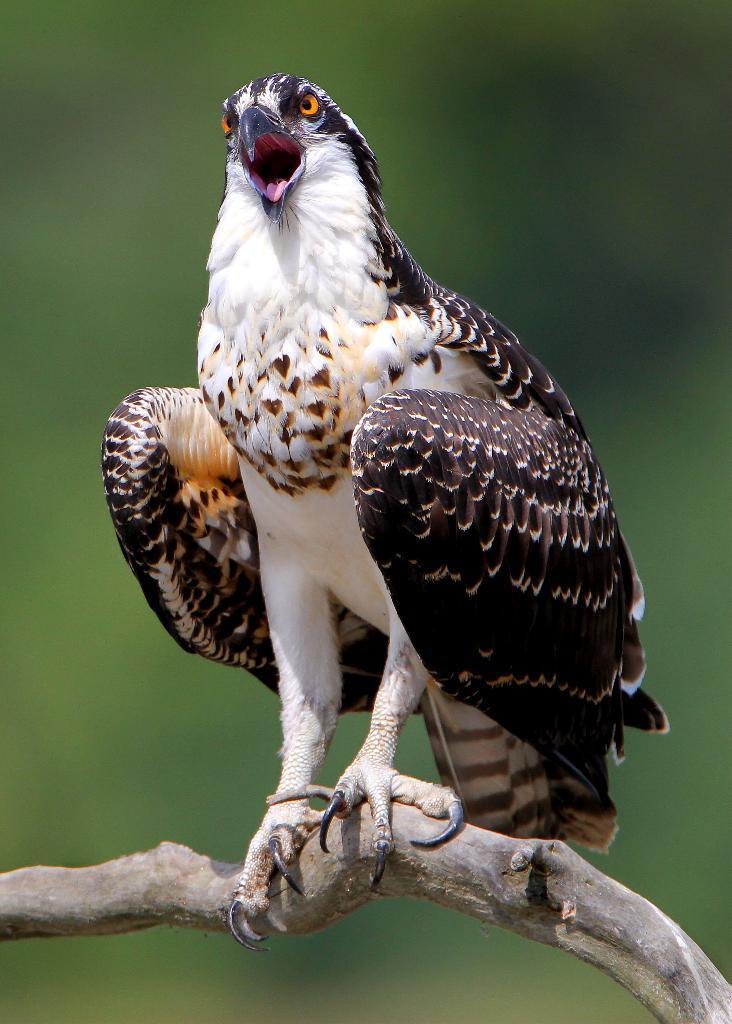How would you summarize this image in a sentence or two? In the foreground of this image, there is a bird on a stem and the background image is blur. 